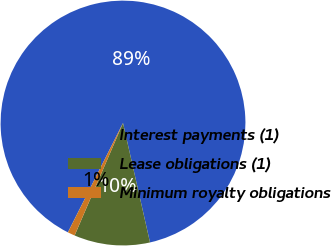Convert chart to OTSL. <chart><loc_0><loc_0><loc_500><loc_500><pie_chart><fcel>Interest payments (1)<fcel>Lease obligations (1)<fcel>Minimum royalty obligations<nl><fcel>89.03%<fcel>10.01%<fcel>0.96%<nl></chart> 